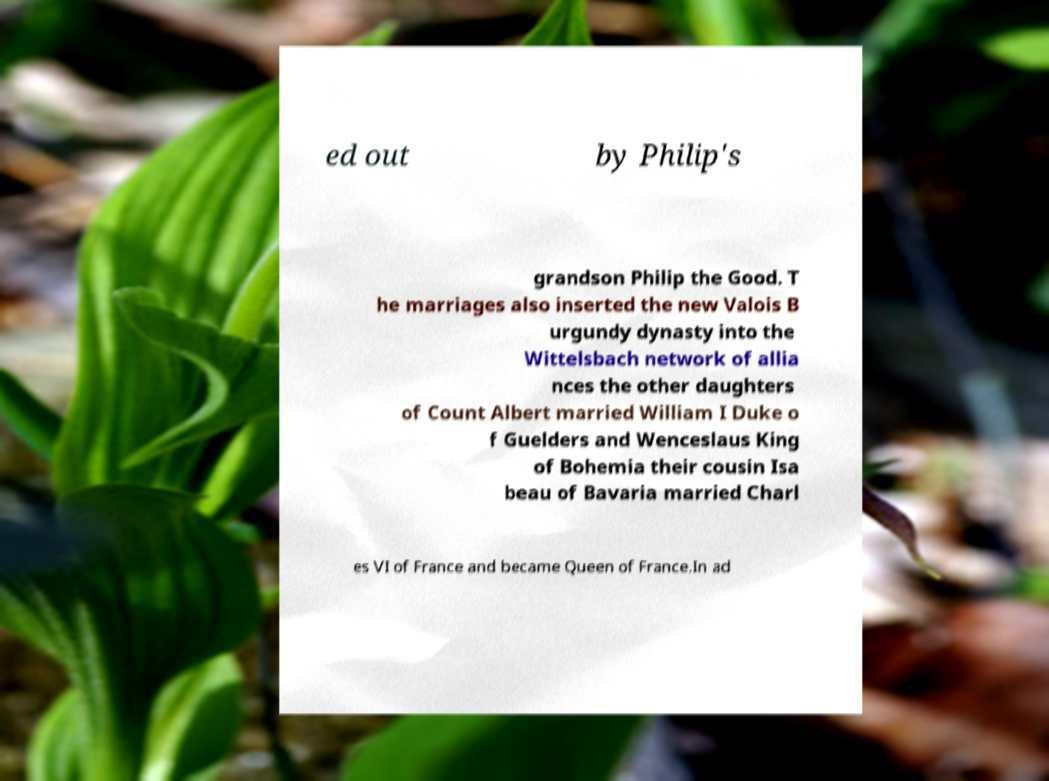Could you assist in decoding the text presented in this image and type it out clearly? ed out by Philip's grandson Philip the Good. T he marriages also inserted the new Valois B urgundy dynasty into the Wittelsbach network of allia nces the other daughters of Count Albert married William I Duke o f Guelders and Wenceslaus King of Bohemia their cousin Isa beau of Bavaria married Charl es VI of France and became Queen of France.In ad 